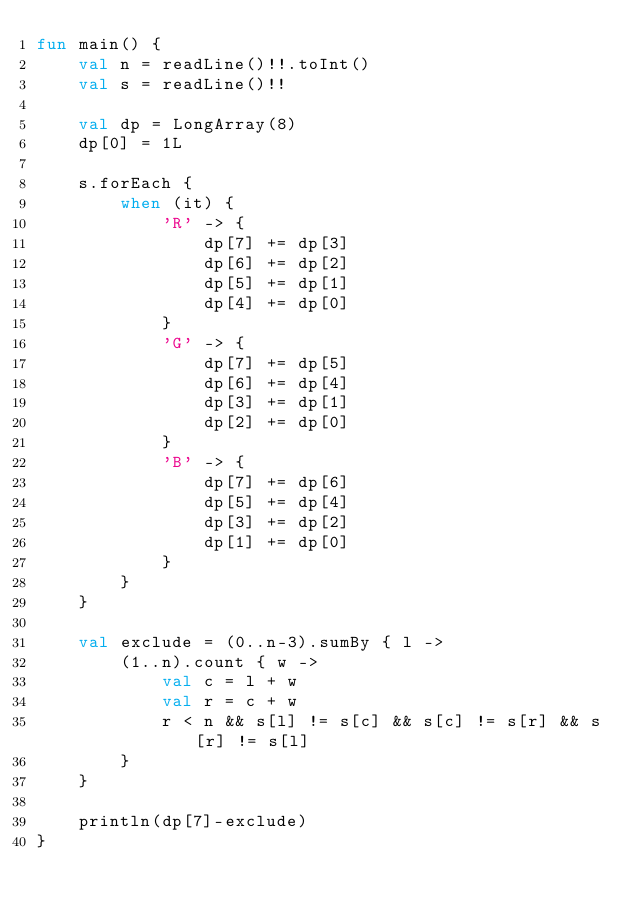Convert code to text. <code><loc_0><loc_0><loc_500><loc_500><_Kotlin_>fun main() {
    val n = readLine()!!.toInt()
    val s = readLine()!!

    val dp = LongArray(8)
    dp[0] = 1L

    s.forEach {
        when (it) {
            'R' -> {
                dp[7] += dp[3]
                dp[6] += dp[2]
                dp[5] += dp[1]
                dp[4] += dp[0]
            }
            'G' -> {
                dp[7] += dp[5]
                dp[6] += dp[4]
                dp[3] += dp[1]
                dp[2] += dp[0]
            }
            'B' -> {
                dp[7] += dp[6]
                dp[5] += dp[4]
                dp[3] += dp[2]
                dp[1] += dp[0]
            }
        }
    }

    val exclude = (0..n-3).sumBy { l ->
        (1..n).count { w ->
            val c = l + w
            val r = c + w
            r < n && s[l] != s[c] && s[c] != s[r] && s[r] != s[l]
        }
    }

    println(dp[7]-exclude)
}</code> 